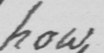What does this handwritten line say? how 